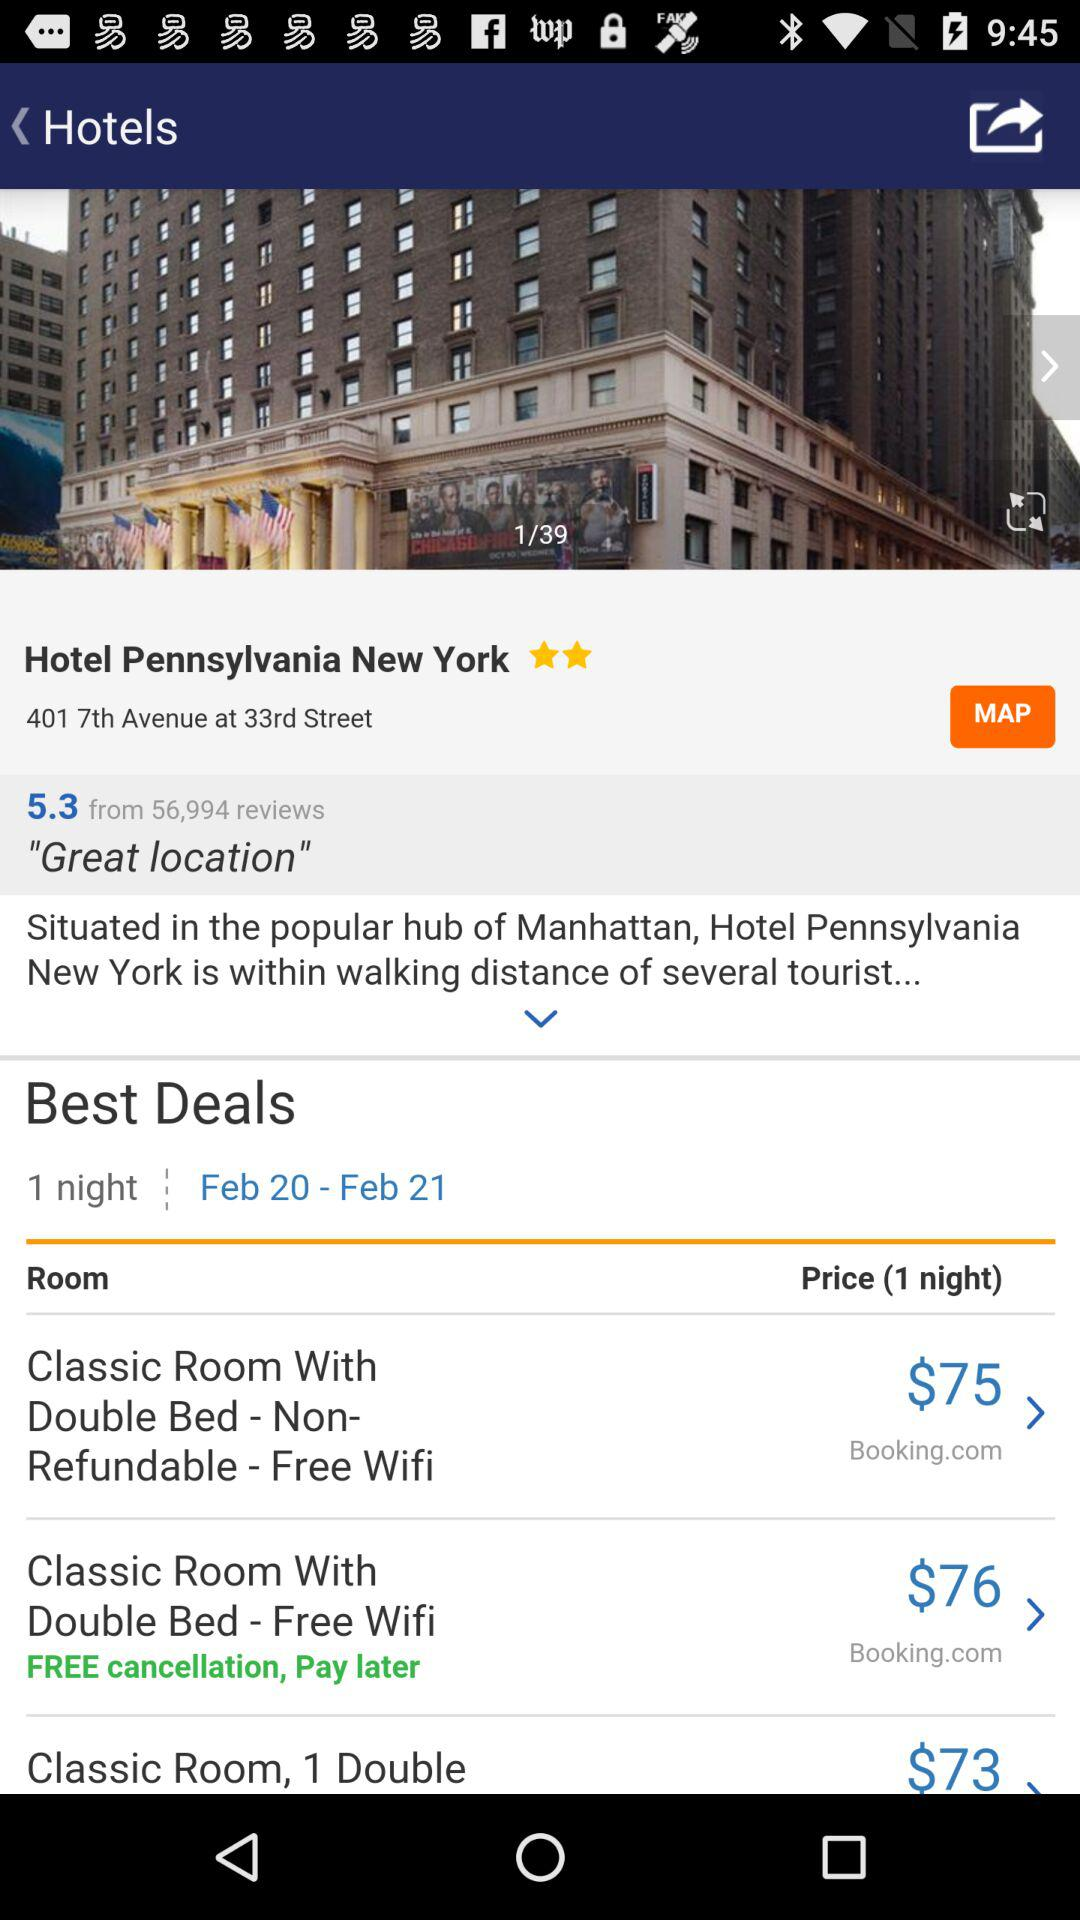What is the star rating of the Hotel Pennsylvania? The rating is 2 stars. 